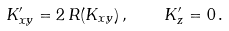Convert formula to latex. <formula><loc_0><loc_0><loc_500><loc_500>K ^ { \prime } _ { x y } = 2 \, R ( K _ { x y } ) \, , \quad K ^ { \prime } _ { z } = 0 \, .</formula> 